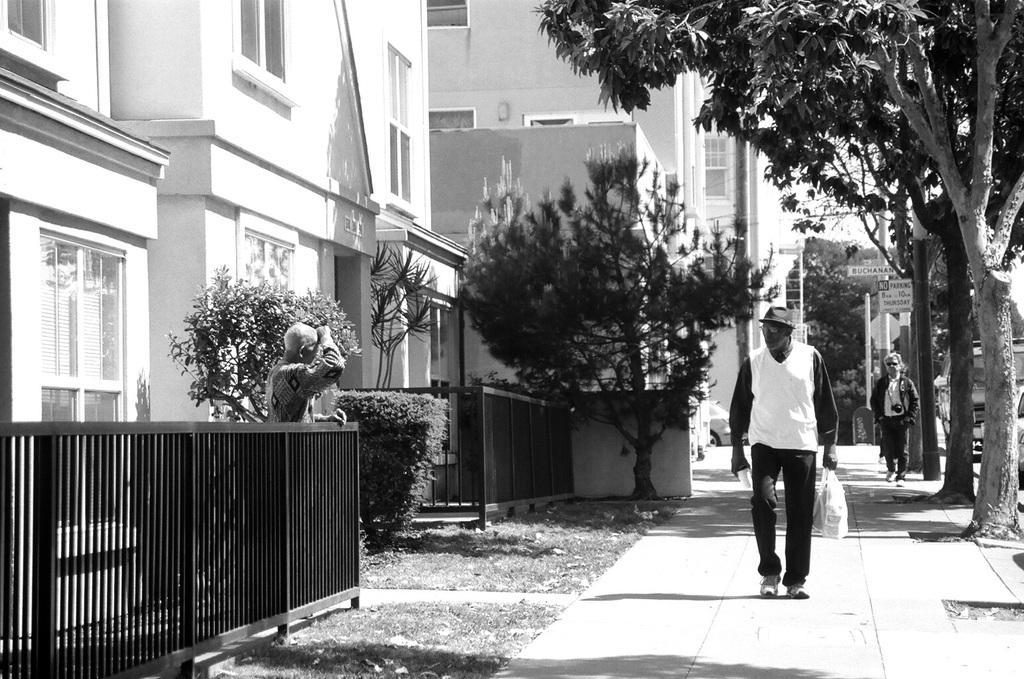Please provide a concise description of this image. This is a black and white image. In the image there are two men walking on the path. On the left side of the image there is a fencing. Behind the fencing there is a person. And also there are small plants and bushes. There are buildings with walls and glass windows. And also there are trees and poles with sign boards in the background. 